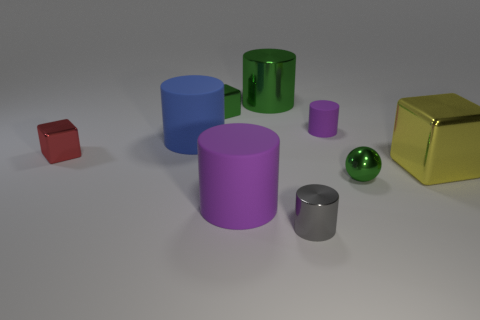Subtract all blue rubber cylinders. How many cylinders are left? 4 Subtract all blue cylinders. How many cylinders are left? 4 Subtract all red cylinders. Subtract all gray spheres. How many cylinders are left? 5 Add 1 blue things. How many objects exist? 10 Subtract all cubes. How many objects are left? 6 Subtract 0 gray balls. How many objects are left? 9 Subtract all green metal spheres. Subtract all tiny purple cylinders. How many objects are left? 7 Add 2 tiny rubber objects. How many tiny rubber objects are left? 3 Add 5 red objects. How many red objects exist? 6 